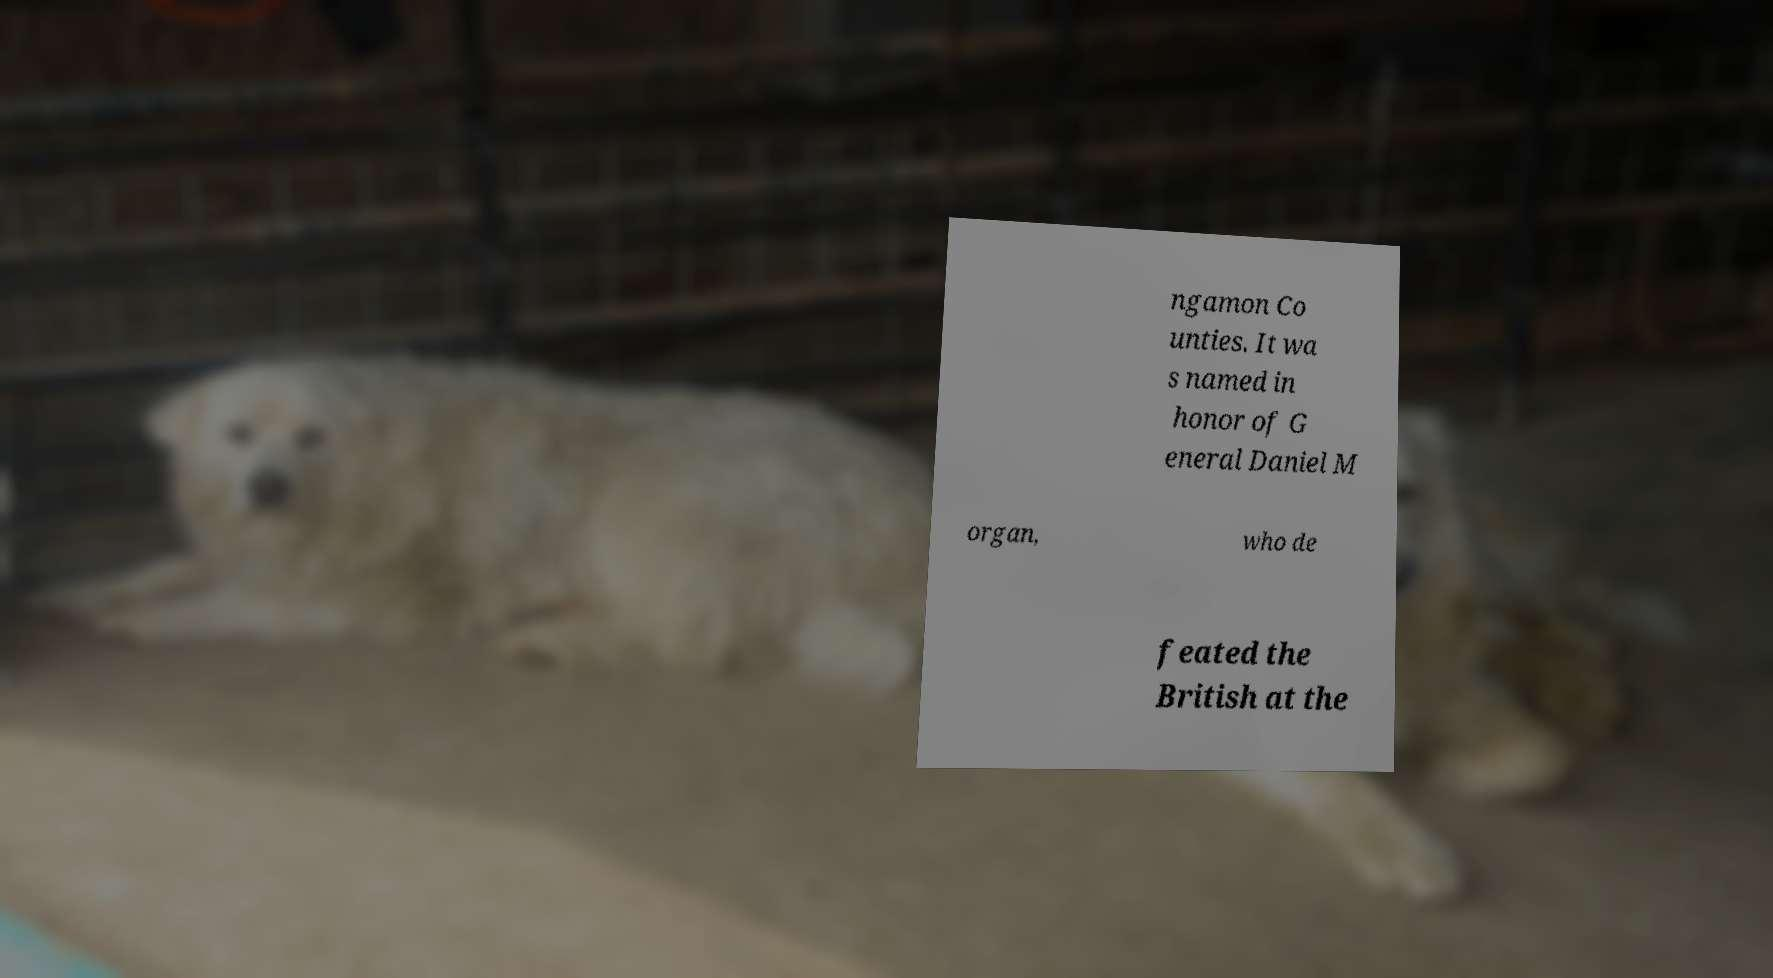Could you extract and type out the text from this image? ngamon Co unties. It wa s named in honor of G eneral Daniel M organ, who de feated the British at the 